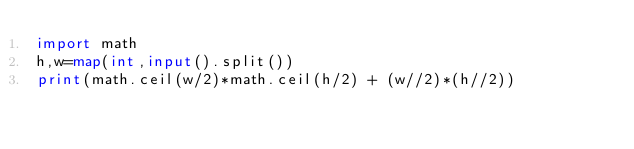Convert code to text. <code><loc_0><loc_0><loc_500><loc_500><_Python_>import math
h,w=map(int,input().split())
print(math.ceil(w/2)*math.ceil(h/2) + (w//2)*(h//2))</code> 